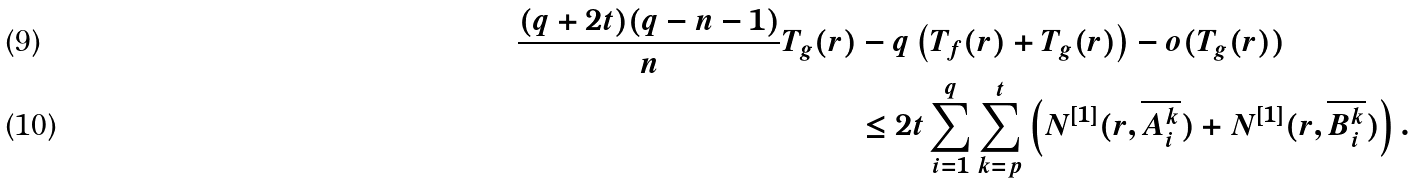<formula> <loc_0><loc_0><loc_500><loc_500>\frac { ( q + 2 t ) ( q - n - 1 ) } { n } T _ { g } ( r ) & - q \left ( T _ { f } ( r ) + T _ { g } ( r ) \right ) - o ( T _ { g } ( r ) ) \\ & \leq 2 t \sum _ { i = 1 } ^ { q } \sum _ { k = p } ^ { t } \left ( N ^ { [ 1 ] } ( r , \overline { A _ { i } ^ { k } } ) + N ^ { [ 1 ] } ( r , \overline { B _ { i } ^ { k } } ) \right ) .</formula> 